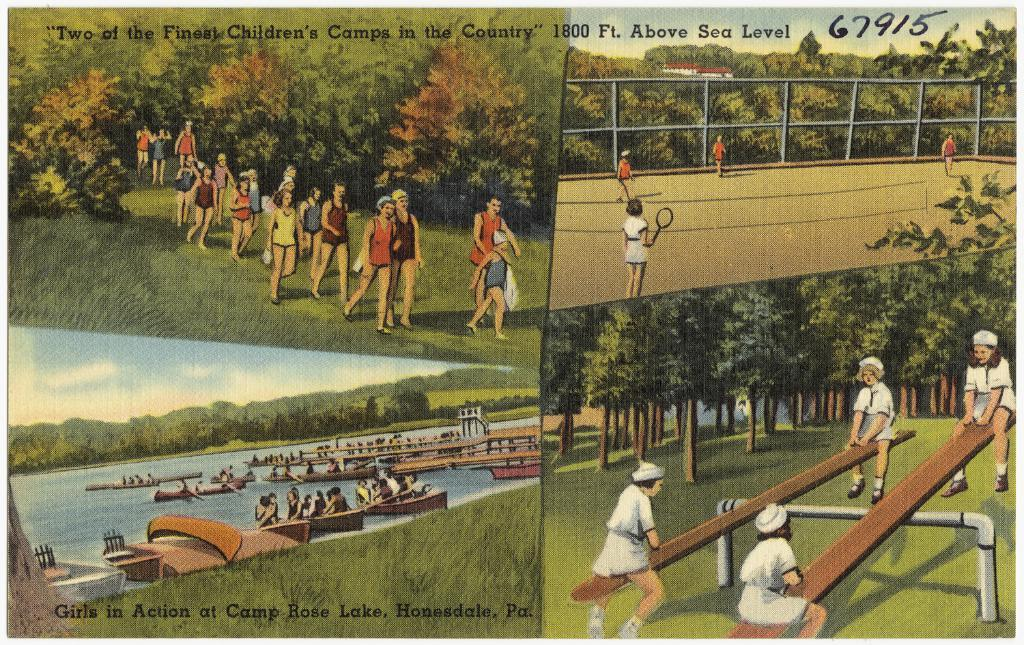Provide a one-sentence caption for the provided image. a painting postcard with for forviews of a camp for children. 